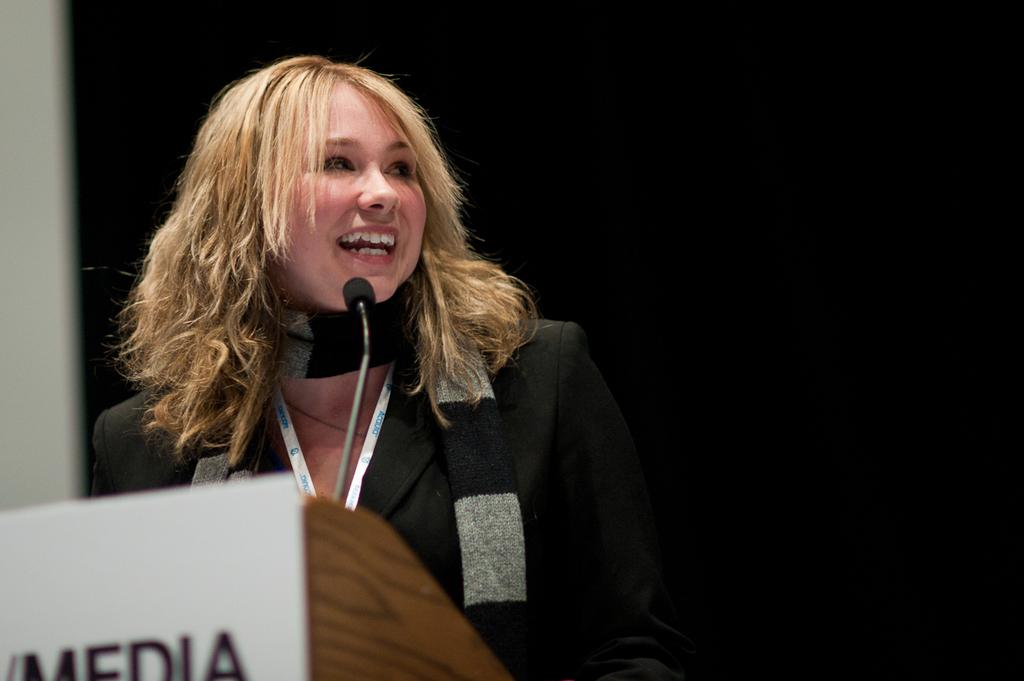Who is the main subject in the image? There is a woman in the image. What is the woman wearing? The woman is wearing a suit. What expression does the woman have? The woman is smiling. Where is the woman located in the image? She is standing near a speech desk. What object is present for amplifying her voice? A microphone is present. How would you describe the lighting in the image? The background of the image appears dark. Can you see any stars in the image? There are no stars visible in the image. What type of polish is the woman applying to her nails in the image? The woman is not applying any polish to her nails in the image; she is wearing a suit and standing near a speech desk. 